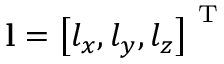<formula> <loc_0><loc_0><loc_500><loc_500>l = \left [ l _ { x } , l _ { y } , l _ { z } \right ] ^ { T }</formula> 